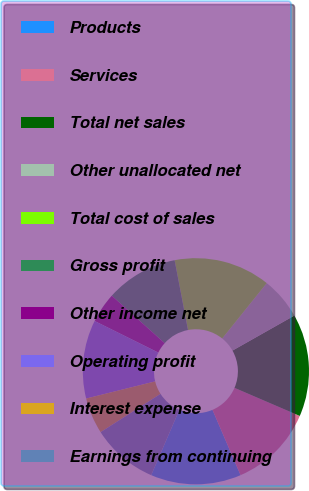Convert chart. <chart><loc_0><loc_0><loc_500><loc_500><pie_chart><fcel>Products<fcel>Services<fcel>Total net sales<fcel>Other unallocated net<fcel>Total cost of sales<fcel>Gross profit<fcel>Other income net<fcel>Operating profit<fcel>Interest expense<fcel>Earnings from continuing<nl><fcel>12.93%<fcel>12.07%<fcel>14.66%<fcel>6.03%<fcel>13.79%<fcel>10.34%<fcel>4.31%<fcel>11.21%<fcel>5.17%<fcel>9.48%<nl></chart> 